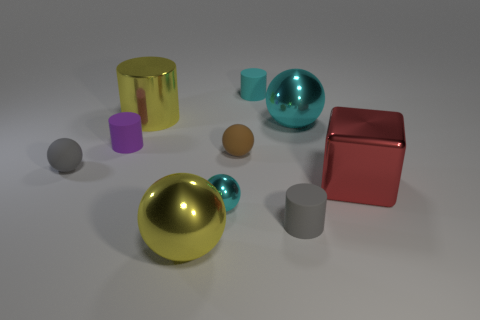Subtract all brown spheres. How many spheres are left? 4 Subtract all small shiny balls. How many balls are left? 4 Subtract all blue spheres. Subtract all green cubes. How many spheres are left? 5 Subtract all cylinders. How many objects are left? 6 Subtract all gray cylinders. Subtract all small cyan spheres. How many objects are left? 8 Add 5 red objects. How many red objects are left? 6 Add 7 purple rubber objects. How many purple rubber objects exist? 8 Subtract 2 cyan balls. How many objects are left? 8 